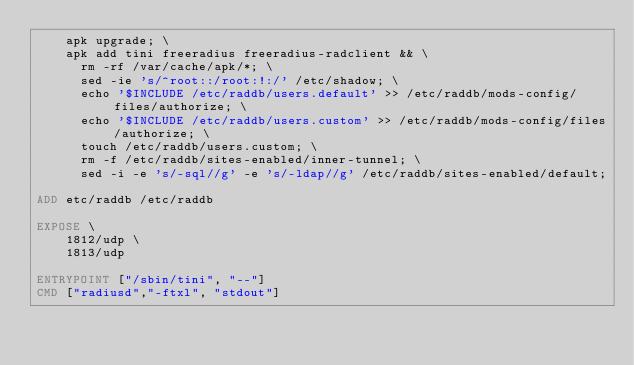<code> <loc_0><loc_0><loc_500><loc_500><_Dockerfile_>    apk upgrade; \
    apk add tini freeradius freeradius-radclient && \
      rm -rf /var/cache/apk/*; \
      sed -ie 's/^root::/root:!:/' /etc/shadow; \
      echo '$INCLUDE /etc/raddb/users.default' >> /etc/raddb/mods-config/files/authorize; \
      echo '$INCLUDE /etc/raddb/users.custom' >> /etc/raddb/mods-config/files/authorize; \
      touch /etc/raddb/users.custom; \
      rm -f /etc/raddb/sites-enabled/inner-tunnel; \
      sed -i -e 's/-sql//g' -e 's/-ldap//g' /etc/raddb/sites-enabled/default;

ADD etc/raddb /etc/raddb

EXPOSE \
    1812/udp \
    1813/udp

ENTRYPOINT ["/sbin/tini", "--"]
CMD ["radiusd","-ftxl", "stdout"]
</code> 